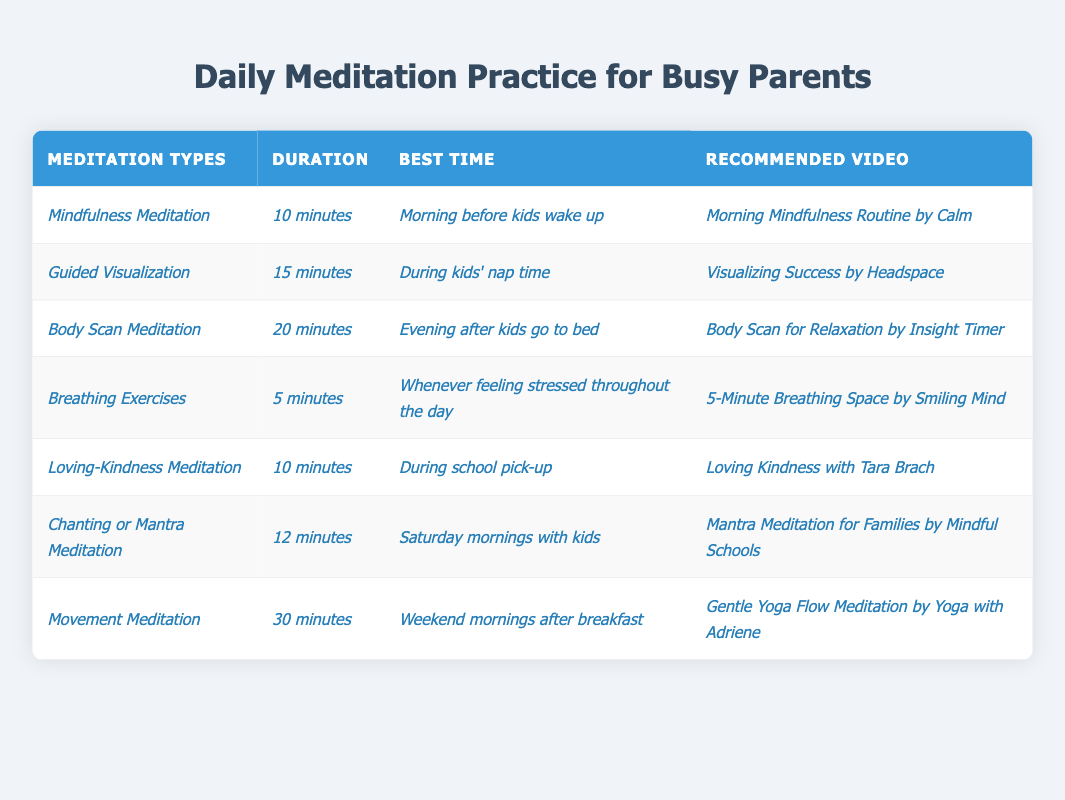What is the duration of Mindfulness Meditation? The table lists the duration of Mindfulness Meditation as *10 minutes*.
Answer: 10 minutes Which meditation type is recommended during kids' nap time? The table indicates that *Guided Visualization* is suggested during kids' nap time.
Answer: Guided Visualization How many different meditation types are listed in the table? There are a total of 7 meditation types mentioned in the table.
Answer: 7 What is the longest meditation type in terms of duration? The longest meditation type is *Movement Meditation* with a duration of *30 minutes*.
Answer: Movement Meditation Is there any meditation type that can be practiced whenever feeling stressed? Yes, *Breathing Exercises* can be practiced whenever feeling stressed throughout the day.
Answer: Yes What is the average duration of all meditation types listed? The durations are 10, 15, 20, 5, 10, 12, and 30 minutes. Sum: 10 + 15 + 20 + 5 + 10 + 12 + 30 = 102 minutes. There are 7 types, so the average is 102/7 ≈ 14.57 minutes.
Answer: 14.57 minutes Which meditation type is associated with Saturday mornings? The table shows that *Chanting or Mantra Meditation* is associated with Saturday mornings with kids.
Answer: Chanting or Mantra Meditation Can *Loving-Kindness Meditation* be practiced in the evening? No, *Loving-Kindness Meditation* is recommended during school pick-up, not in the evening.
Answer: No What is the total time required for all meditation types if one practices each once? The durations of all meditation types are 10, 15, 20, 5, 10, 12, and 30 minutes. Adding them: 10 + 15 + 20 + 5 + 10 + 12 + 30 = 102 minutes in total.
Answer: 102 minutes Is there a meditation type that is longer than 25 minutes? Yes, *Movement Meditation*, lasting *30 minutes*, is longer than 25 minutes.
Answer: Yes 